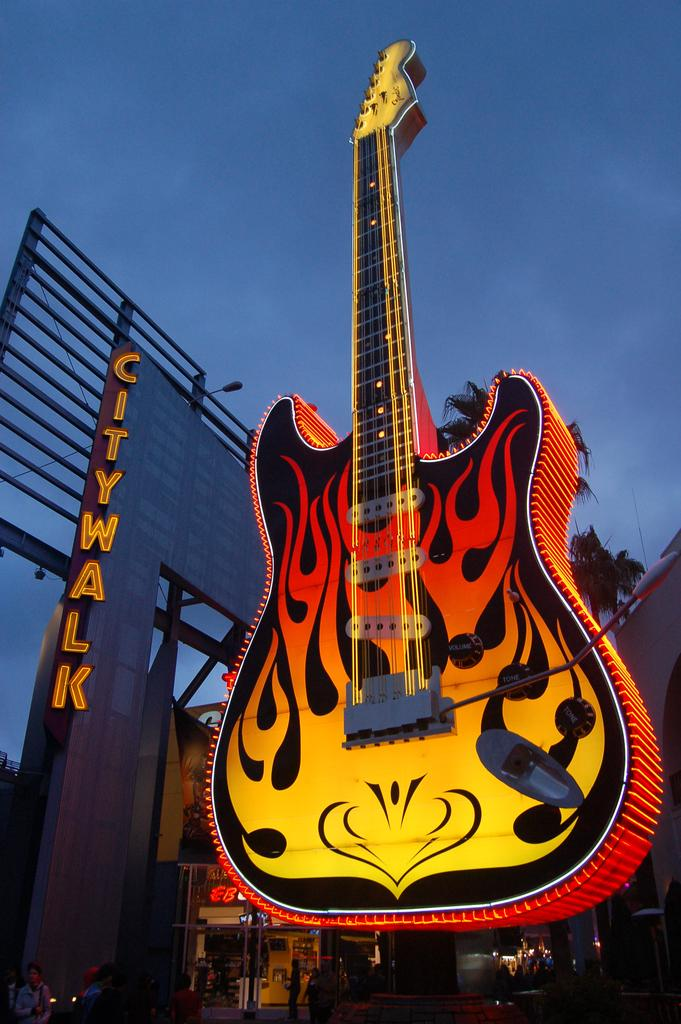What musical instrument is present in the image? There is a guitar in the image. Where is the guitar located? The guitar is on a building. What can be seen in the background of the image? The sky is visible in the image. What type of vegetation is present in the image? There is a tree in the image. What color is the crayon used to draw the tree in the image? There is no crayon present in the image, and the tree is not drawn; it is a real tree. 